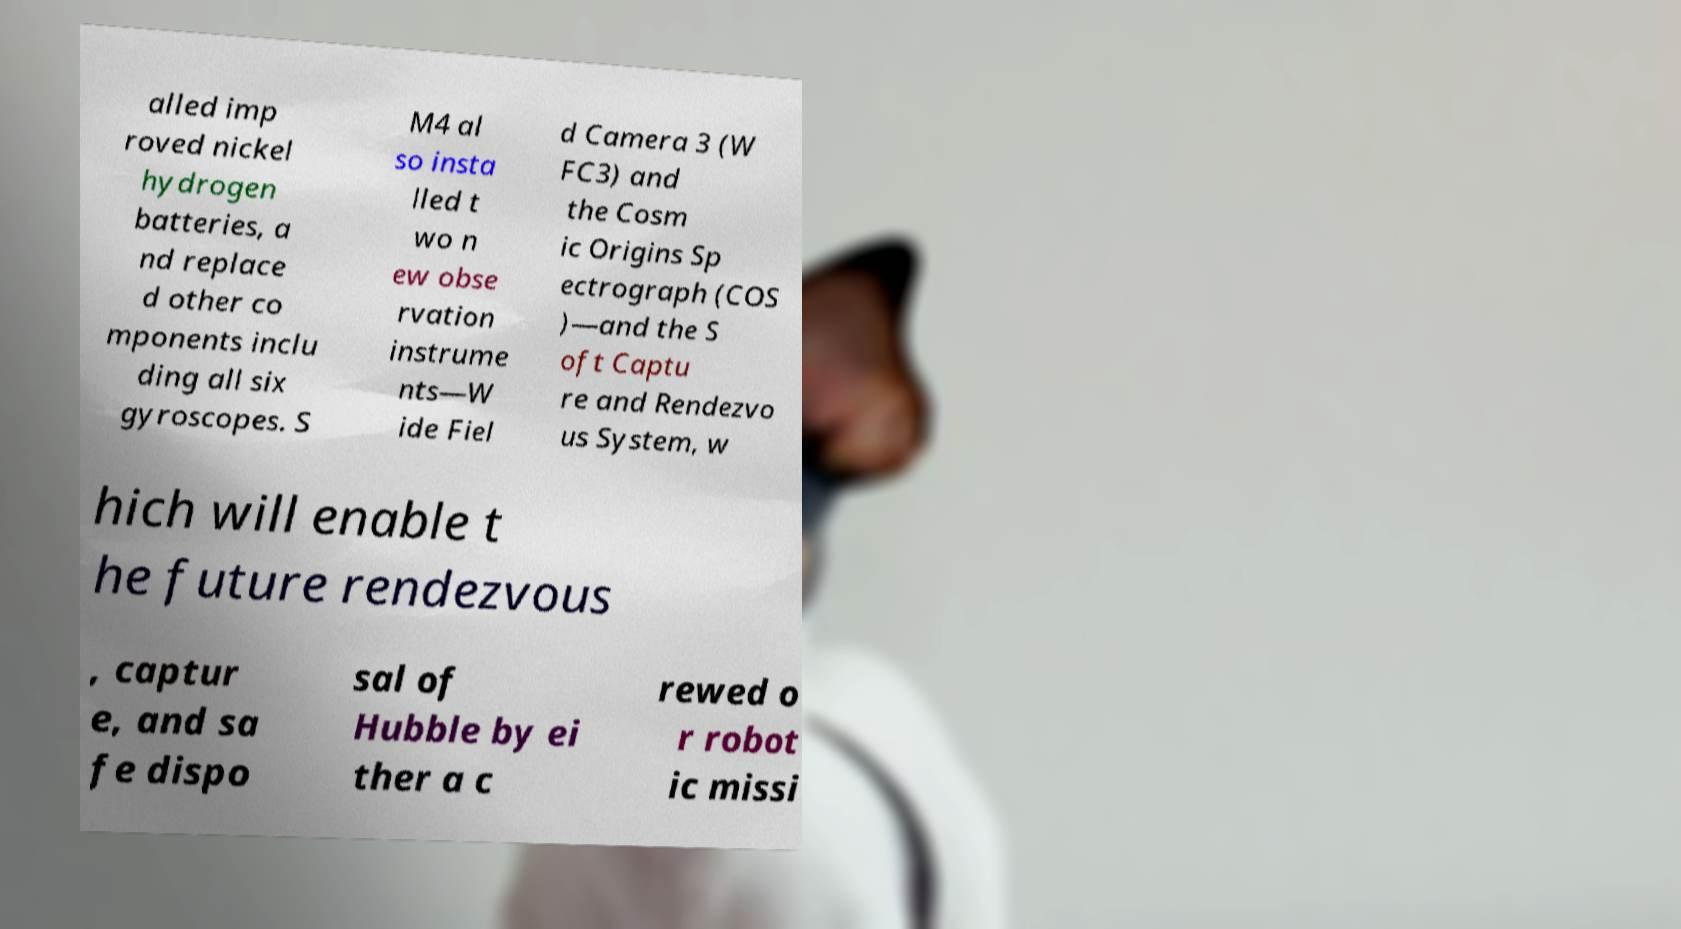What messages or text are displayed in this image? I need them in a readable, typed format. alled imp roved nickel hydrogen batteries, a nd replace d other co mponents inclu ding all six gyroscopes. S M4 al so insta lled t wo n ew obse rvation instrume nts—W ide Fiel d Camera 3 (W FC3) and the Cosm ic Origins Sp ectrograph (COS )—and the S oft Captu re and Rendezvo us System, w hich will enable t he future rendezvous , captur e, and sa fe dispo sal of Hubble by ei ther a c rewed o r robot ic missi 